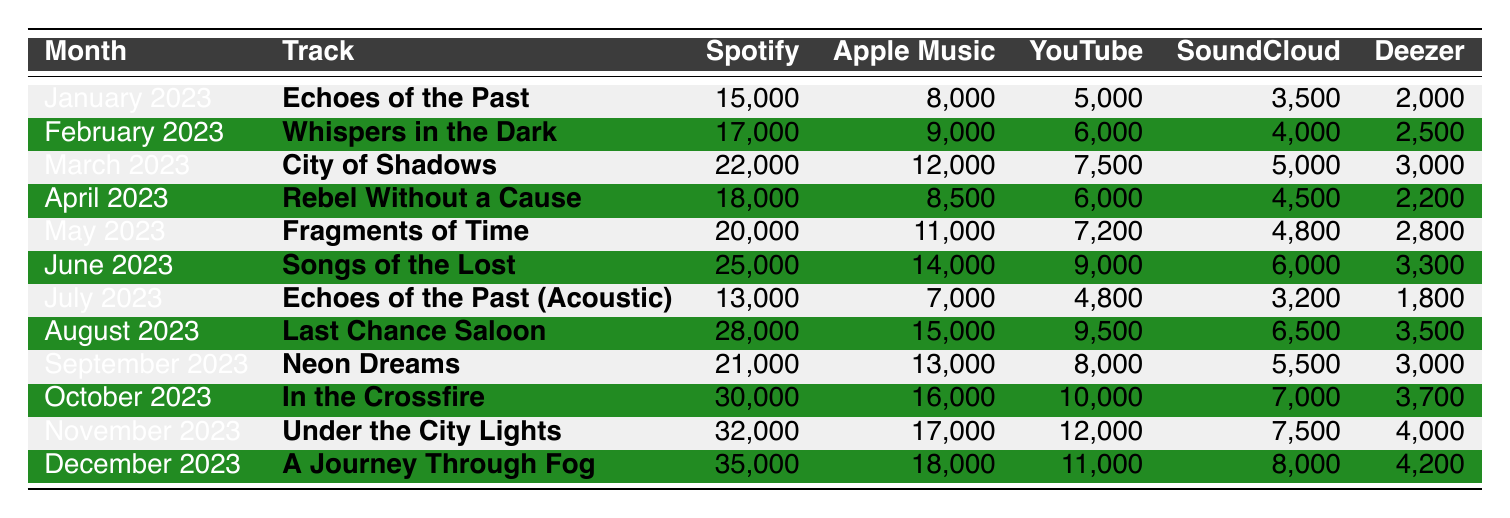What track had the highest Spotify streams in December 2023? In December 2023, the track "A Journey Through Fog" had the highest Spotify streams with a total of 35,000 streams.
Answer: A Journey Through Fog Which track had the lowest SoundCloud streams in July 2023? The lowest SoundCloud streams in July 2023 were for "Echoes of the Past (Acoustic)" with 3,200 streams.
Answer: Echoes of the Past (Acoustic) What is the total number of Spotify streams for "Neon Dreams" across all months? "Neon Dreams" had 21,000 streams in September 2023, and no other month, so its total across all months is 21,000.
Answer: 21,000 Which month had the most YouTube streams, and how many were there? August 2023 had the most YouTube streams with a total of 9,500 streams.
Answer: August 2023, 9,500 What was the average number of Apple Music streams for all tracks in October, November, and December 2023? The Apple Music streams for those months are 16,000 (October), 17,000 (November), and 18,000 (December). Summing them gives 51,000 and dividing by 3 gives an average of 17,000.
Answer: 17,000 Did "Fragments of Time" have more streams on Deezer than "Rebel Without a Cause"? Yes, "Fragments of Time" had 2,800 streams on Deezer compared to 2,200 for "Rebel Without a Cause", making the statement true.
Answer: Yes Which track had the highest total streams (all platforms combined) in June 2023? Adding all streams for "Songs of the Lost" in June gives: 25,000 (Spotify) + 14,000 (Apple Music) + 9,000 (YouTube) + 6,000 (SoundCloud) + 3,300 (Deezer) = 57,300.
Answer: Songs of the Lost What is the total change in Spotify streams from March to December 2023? The Spotify streams in March 2023 were 22,000 and in December 2023 they were 35,000. The difference is 35,000 - 22,000 = 13,000.
Answer: 13,000 In which month did "Whispers in the Dark" perform best on Apple Music? "Whispers in the Dark" had its highest streams on Apple Music in February 2023 with 9,000 streams.
Answer: February 2023 What was the highest total of SoundCloud streams in any single month and which month was it? August 2023 had the highest SoundCloud streams with a total of 6,500.
Answer: August 2023, 6,500 